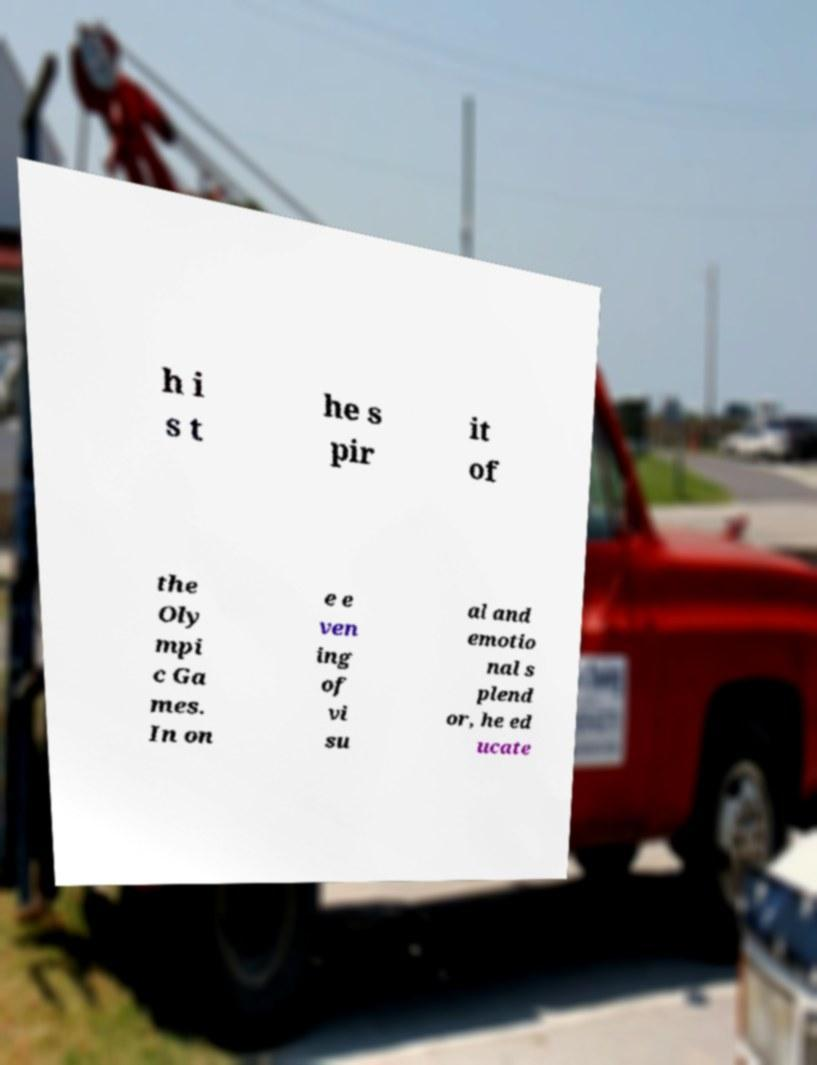For documentation purposes, I need the text within this image transcribed. Could you provide that? h i s t he s pir it of the Oly mpi c Ga mes. In on e e ven ing of vi su al and emotio nal s plend or, he ed ucate 